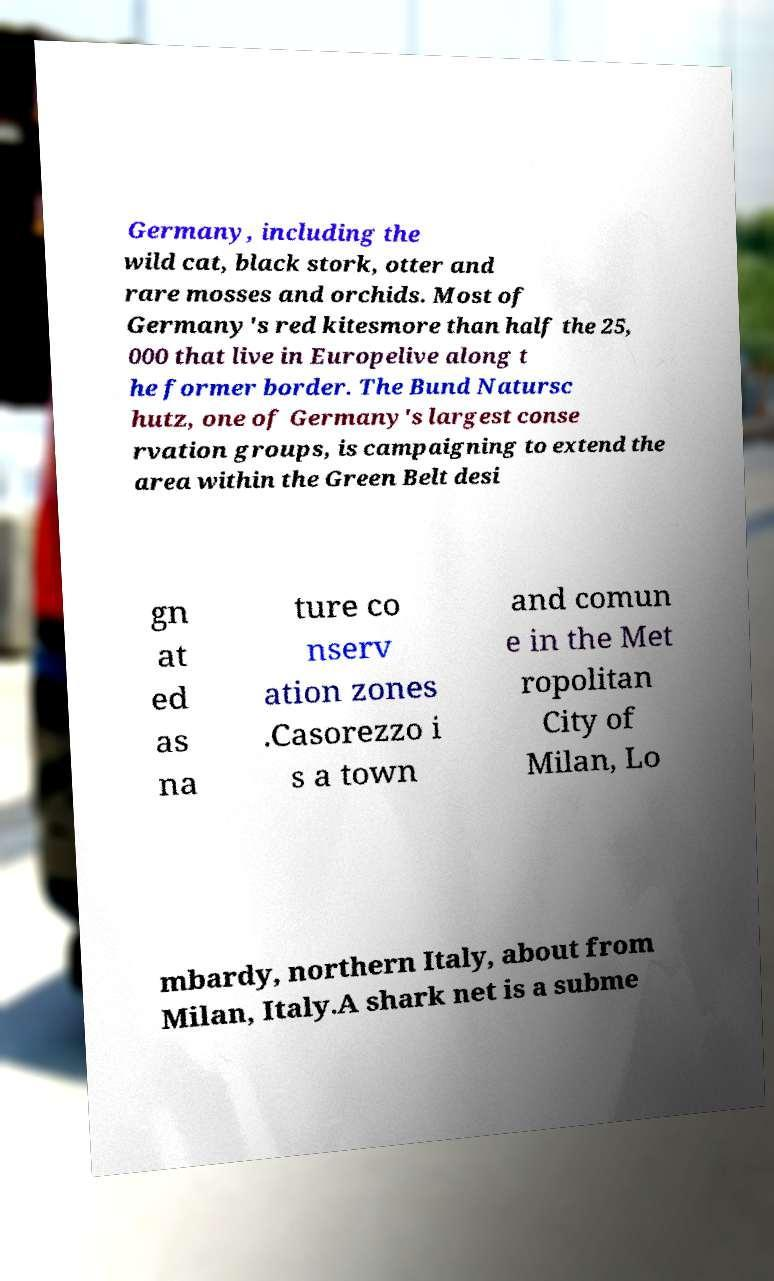For documentation purposes, I need the text within this image transcribed. Could you provide that? Germany, including the wild cat, black stork, otter and rare mosses and orchids. Most of Germany's red kitesmore than half the 25, 000 that live in Europelive along t he former border. The Bund Natursc hutz, one of Germany's largest conse rvation groups, is campaigning to extend the area within the Green Belt desi gn at ed as na ture co nserv ation zones .Casorezzo i s a town and comun e in the Met ropolitan City of Milan, Lo mbardy, northern Italy, about from Milan, Italy.A shark net is a subme 